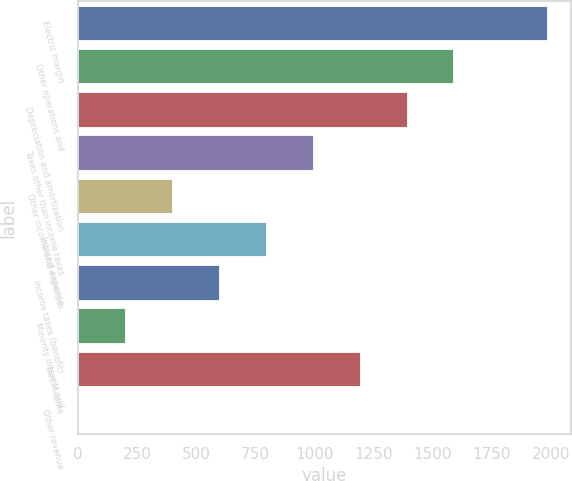Convert chart to OTSL. <chart><loc_0><loc_0><loc_500><loc_500><bar_chart><fcel>Electric margin<fcel>Other operations and<fcel>Depreciation and amortization<fcel>Taxes other than income taxes<fcel>Other income and expenses<fcel>Interest expense<fcel>Income taxes (benefit)<fcel>Minority interest and<fcel>Net Income<fcel>Other revenue<nl><fcel>1984<fcel>1587.6<fcel>1389.4<fcel>993<fcel>398.4<fcel>794.8<fcel>596.6<fcel>200.2<fcel>1191.2<fcel>2<nl></chart> 